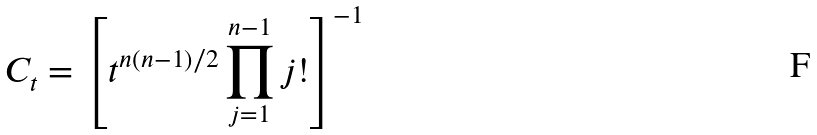<formula> <loc_0><loc_0><loc_500><loc_500>C _ { t } = \left [ t ^ { n ( n - 1 ) / 2 } \prod _ { j = 1 } ^ { n - 1 } j ! \right ] ^ { - 1 }</formula> 